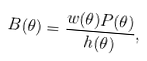Convert formula to latex. <formula><loc_0><loc_0><loc_500><loc_500>B ( \theta ) = \frac { w ( \theta ) P ( \theta ) } { h ( \theta ) } ,</formula> 